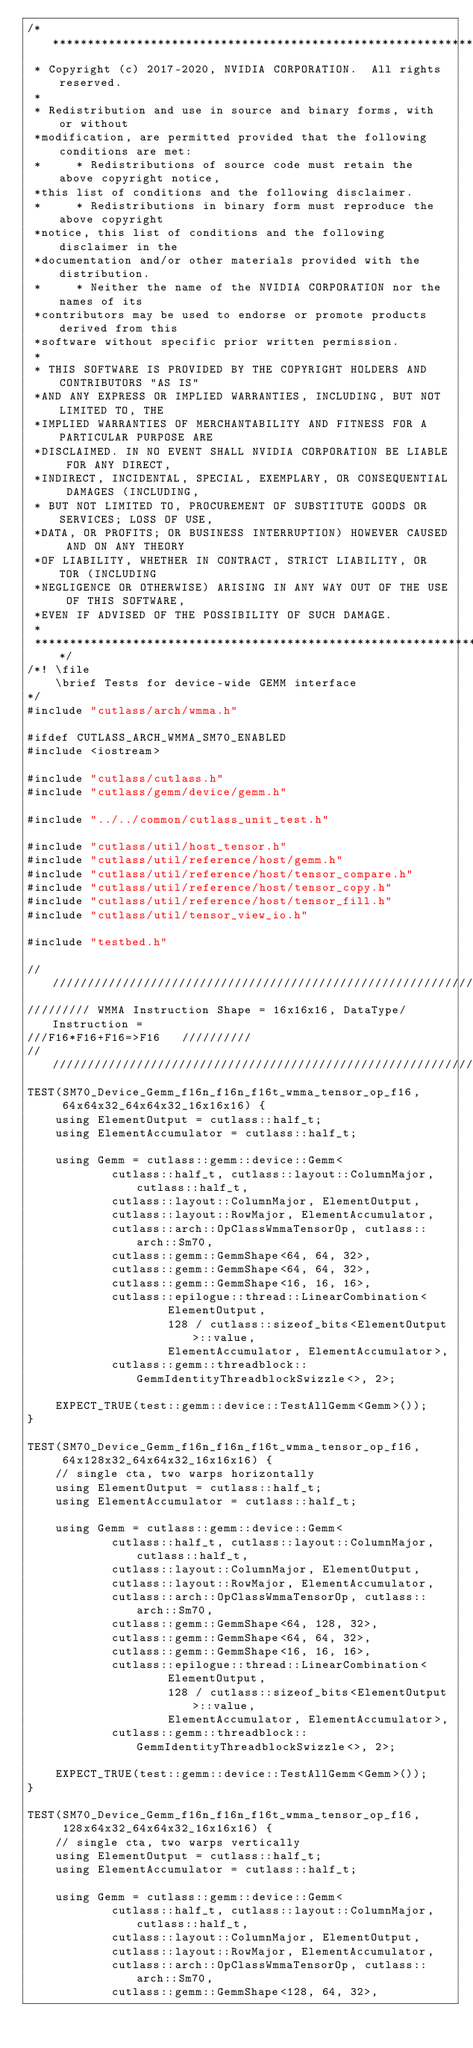<code> <loc_0><loc_0><loc_500><loc_500><_Cuda_>/***************************************************************************************************
 * Copyright (c) 2017-2020, NVIDIA CORPORATION.  All rights reserved.
 *
 * Redistribution and use in source and binary forms, with or without
 *modification, are permitted provided that the following conditions are met:
 *     * Redistributions of source code must retain the above copyright notice,
 *this list of conditions and the following disclaimer.
 *     * Redistributions in binary form must reproduce the above copyright
 *notice, this list of conditions and the following disclaimer in the
 *documentation and/or other materials provided with the distribution.
 *     * Neither the name of the NVIDIA CORPORATION nor the names of its
 *contributors may be used to endorse or promote products derived from this
 *software without specific prior written permission.
 *
 * THIS SOFTWARE IS PROVIDED BY THE COPYRIGHT HOLDERS AND CONTRIBUTORS "AS IS"
 *AND ANY EXPRESS OR IMPLIED WARRANTIES, INCLUDING, BUT NOT LIMITED TO, THE
 *IMPLIED WARRANTIES OF MERCHANTABILITY AND FITNESS FOR A PARTICULAR PURPOSE ARE
 *DISCLAIMED. IN NO EVENT SHALL NVIDIA CORPORATION BE LIABLE FOR ANY DIRECT,
 *INDIRECT, INCIDENTAL, SPECIAL, EXEMPLARY, OR CONSEQUENTIAL DAMAGES (INCLUDING,
 * BUT NOT LIMITED TO, PROCUREMENT OF SUBSTITUTE GOODS OR SERVICES; LOSS OF USE,
 *DATA, OR PROFITS; OR BUSINESS INTERRUPTION) HOWEVER CAUSED AND ON ANY THEORY
 *OF LIABILITY, WHETHER IN CONTRACT, STRICT LIABILITY, OR TOR (INCLUDING
 *NEGLIGENCE OR OTHERWISE) ARISING IN ANY WAY OUT OF THE USE OF THIS SOFTWARE,
 *EVEN IF ADVISED OF THE POSSIBILITY OF SUCH DAMAGE.
 *
 **************************************************************************************************/
/*! \file
    \brief Tests for device-wide GEMM interface
*/
#include "cutlass/arch/wmma.h"

#ifdef CUTLASS_ARCH_WMMA_SM70_ENABLED
#include <iostream>

#include "cutlass/cutlass.h"
#include "cutlass/gemm/device/gemm.h"

#include "../../common/cutlass_unit_test.h"

#include "cutlass/util/host_tensor.h"
#include "cutlass/util/reference/host/gemm.h"
#include "cutlass/util/reference/host/tensor_compare.h"
#include "cutlass/util/reference/host/tensor_copy.h"
#include "cutlass/util/reference/host/tensor_fill.h"
#include "cutlass/util/tensor_view_io.h"

#include "testbed.h"

/////////////////////////////////////////////////////////////////////////////////////////////////
///////// WMMA Instruction Shape = 16x16x16, DataType/Instruction =
///F16*F16+F16=>F16   //////////
/////////////////////////////////////////////////////////////////////////////////////////////////
TEST(SM70_Device_Gemm_f16n_f16n_f16t_wmma_tensor_op_f16,
     64x64x32_64x64x32_16x16x16) {
    using ElementOutput = cutlass::half_t;
    using ElementAccumulator = cutlass::half_t;

    using Gemm = cutlass::gemm::device::Gemm<
            cutlass::half_t, cutlass::layout::ColumnMajor, cutlass::half_t,
            cutlass::layout::ColumnMajor, ElementOutput,
            cutlass::layout::RowMajor, ElementAccumulator,
            cutlass::arch::OpClassWmmaTensorOp, cutlass::arch::Sm70,
            cutlass::gemm::GemmShape<64, 64, 32>,
            cutlass::gemm::GemmShape<64, 64, 32>,
            cutlass::gemm::GemmShape<16, 16, 16>,
            cutlass::epilogue::thread::LinearCombination<
                    ElementOutput,
                    128 / cutlass::sizeof_bits<ElementOutput>::value,
                    ElementAccumulator, ElementAccumulator>,
            cutlass::gemm::threadblock::GemmIdentityThreadblockSwizzle<>, 2>;

    EXPECT_TRUE(test::gemm::device::TestAllGemm<Gemm>());
}

TEST(SM70_Device_Gemm_f16n_f16n_f16t_wmma_tensor_op_f16,
     64x128x32_64x64x32_16x16x16) {
    // single cta, two warps horizontally
    using ElementOutput = cutlass::half_t;
    using ElementAccumulator = cutlass::half_t;

    using Gemm = cutlass::gemm::device::Gemm<
            cutlass::half_t, cutlass::layout::ColumnMajor, cutlass::half_t,
            cutlass::layout::ColumnMajor, ElementOutput,
            cutlass::layout::RowMajor, ElementAccumulator,
            cutlass::arch::OpClassWmmaTensorOp, cutlass::arch::Sm70,
            cutlass::gemm::GemmShape<64, 128, 32>,
            cutlass::gemm::GemmShape<64, 64, 32>,
            cutlass::gemm::GemmShape<16, 16, 16>,
            cutlass::epilogue::thread::LinearCombination<
                    ElementOutput,
                    128 / cutlass::sizeof_bits<ElementOutput>::value,
                    ElementAccumulator, ElementAccumulator>,
            cutlass::gemm::threadblock::GemmIdentityThreadblockSwizzle<>, 2>;

    EXPECT_TRUE(test::gemm::device::TestAllGemm<Gemm>());
}

TEST(SM70_Device_Gemm_f16n_f16n_f16t_wmma_tensor_op_f16,
     128x64x32_64x64x32_16x16x16) {
    // single cta, two warps vertically
    using ElementOutput = cutlass::half_t;
    using ElementAccumulator = cutlass::half_t;

    using Gemm = cutlass::gemm::device::Gemm<
            cutlass::half_t, cutlass::layout::ColumnMajor, cutlass::half_t,
            cutlass::layout::ColumnMajor, ElementOutput,
            cutlass::layout::RowMajor, ElementAccumulator,
            cutlass::arch::OpClassWmmaTensorOp, cutlass::arch::Sm70,
            cutlass::gemm::GemmShape<128, 64, 32>,</code> 